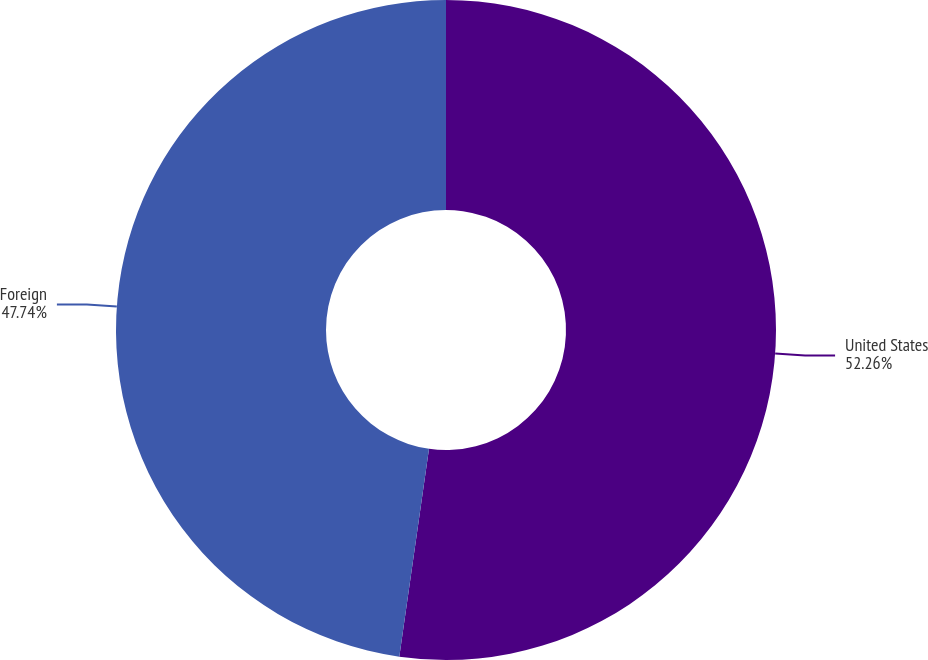Convert chart to OTSL. <chart><loc_0><loc_0><loc_500><loc_500><pie_chart><fcel>United States<fcel>Foreign<nl><fcel>52.26%<fcel>47.74%<nl></chart> 